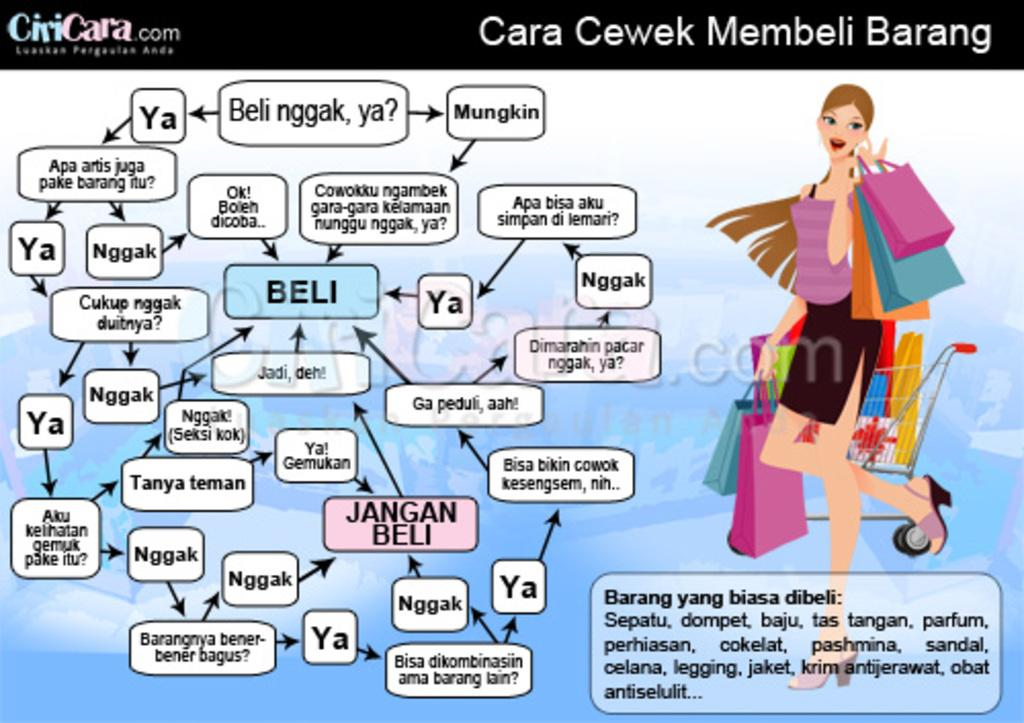What is featured on the poster in the image? There is a poster in the image that contains a cartoon image of a woman. What is the woman in the cartoon doing? The woman in the cartoon is holding shopping bags. Is there any text on the poster? Yes, there is text written on the poster. Can you see a porter using a rake to support the poster in the image? No, there is no porter or rake present in the image. The poster is supported by its own structure, and there is no need for a porter or rake to hold it up. 